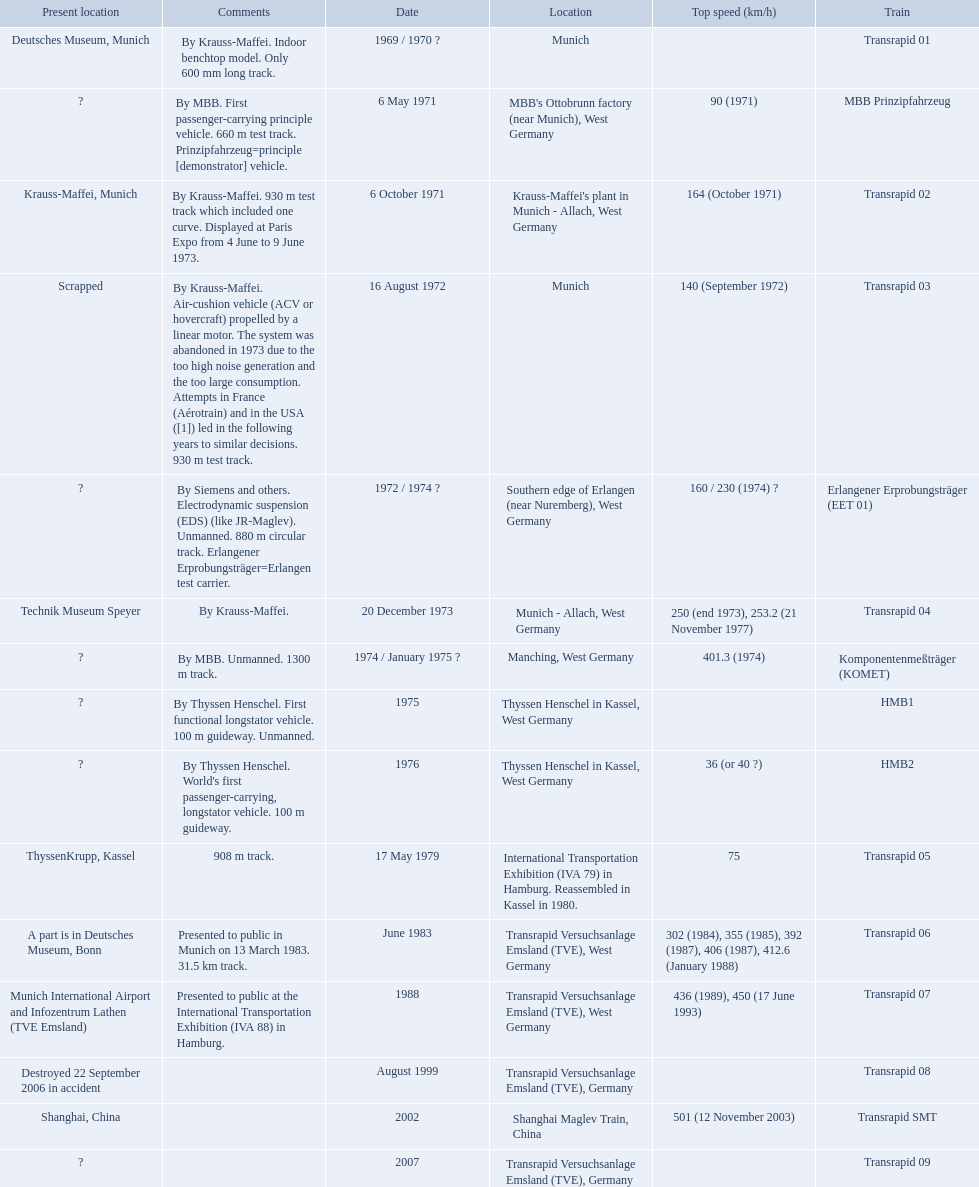What are all trains? Transrapid 01, MBB Prinzipfahrzeug, Transrapid 02, Transrapid 03, Erlangener Erprobungsträger (EET 01), Transrapid 04, Komponentenmeßträger (KOMET), HMB1, HMB2, Transrapid 05, Transrapid 06, Transrapid 07, Transrapid 08, Transrapid SMT, Transrapid 09. Which of all location of trains are known? Deutsches Museum, Munich, Krauss-Maffei, Munich, Scrapped, Technik Museum Speyer, ThyssenKrupp, Kassel, A part is in Deutsches Museum, Bonn, Munich International Airport and Infozentrum Lathen (TVE Emsland), Destroyed 22 September 2006 in accident, Shanghai, China. Which of those trains were scrapped? Transrapid 03. 